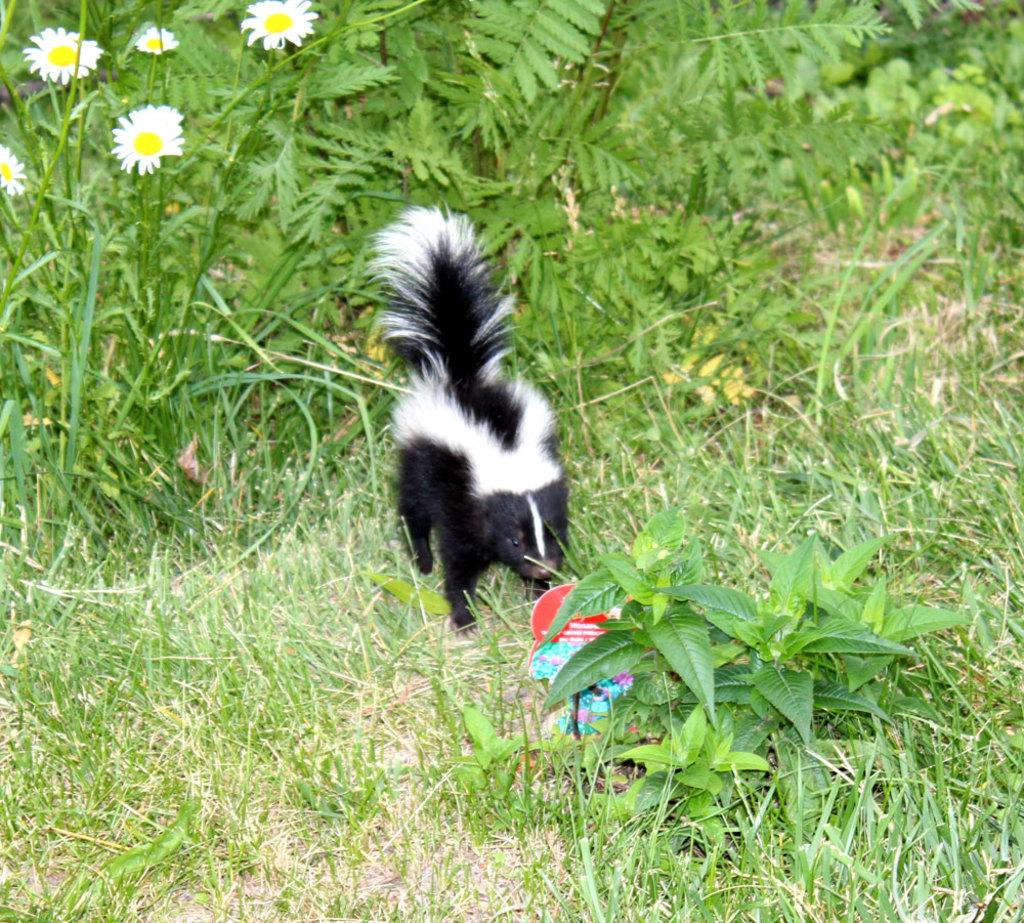What type of creature is in the image? There is an animal in the image. What color is the animal? The animal is in black and white color. What can be seen on the left side of the image? There are flower plants on the left side of the image. What type of vegetation is at the bottom of the image? There is grass at the bottom of the image. Where is the sink located in the image? There is no sink present in the image. What type of crack can be seen on the animal's body in the image? There is no crack visible on the animal's body in the image, as it is in black and white color. 